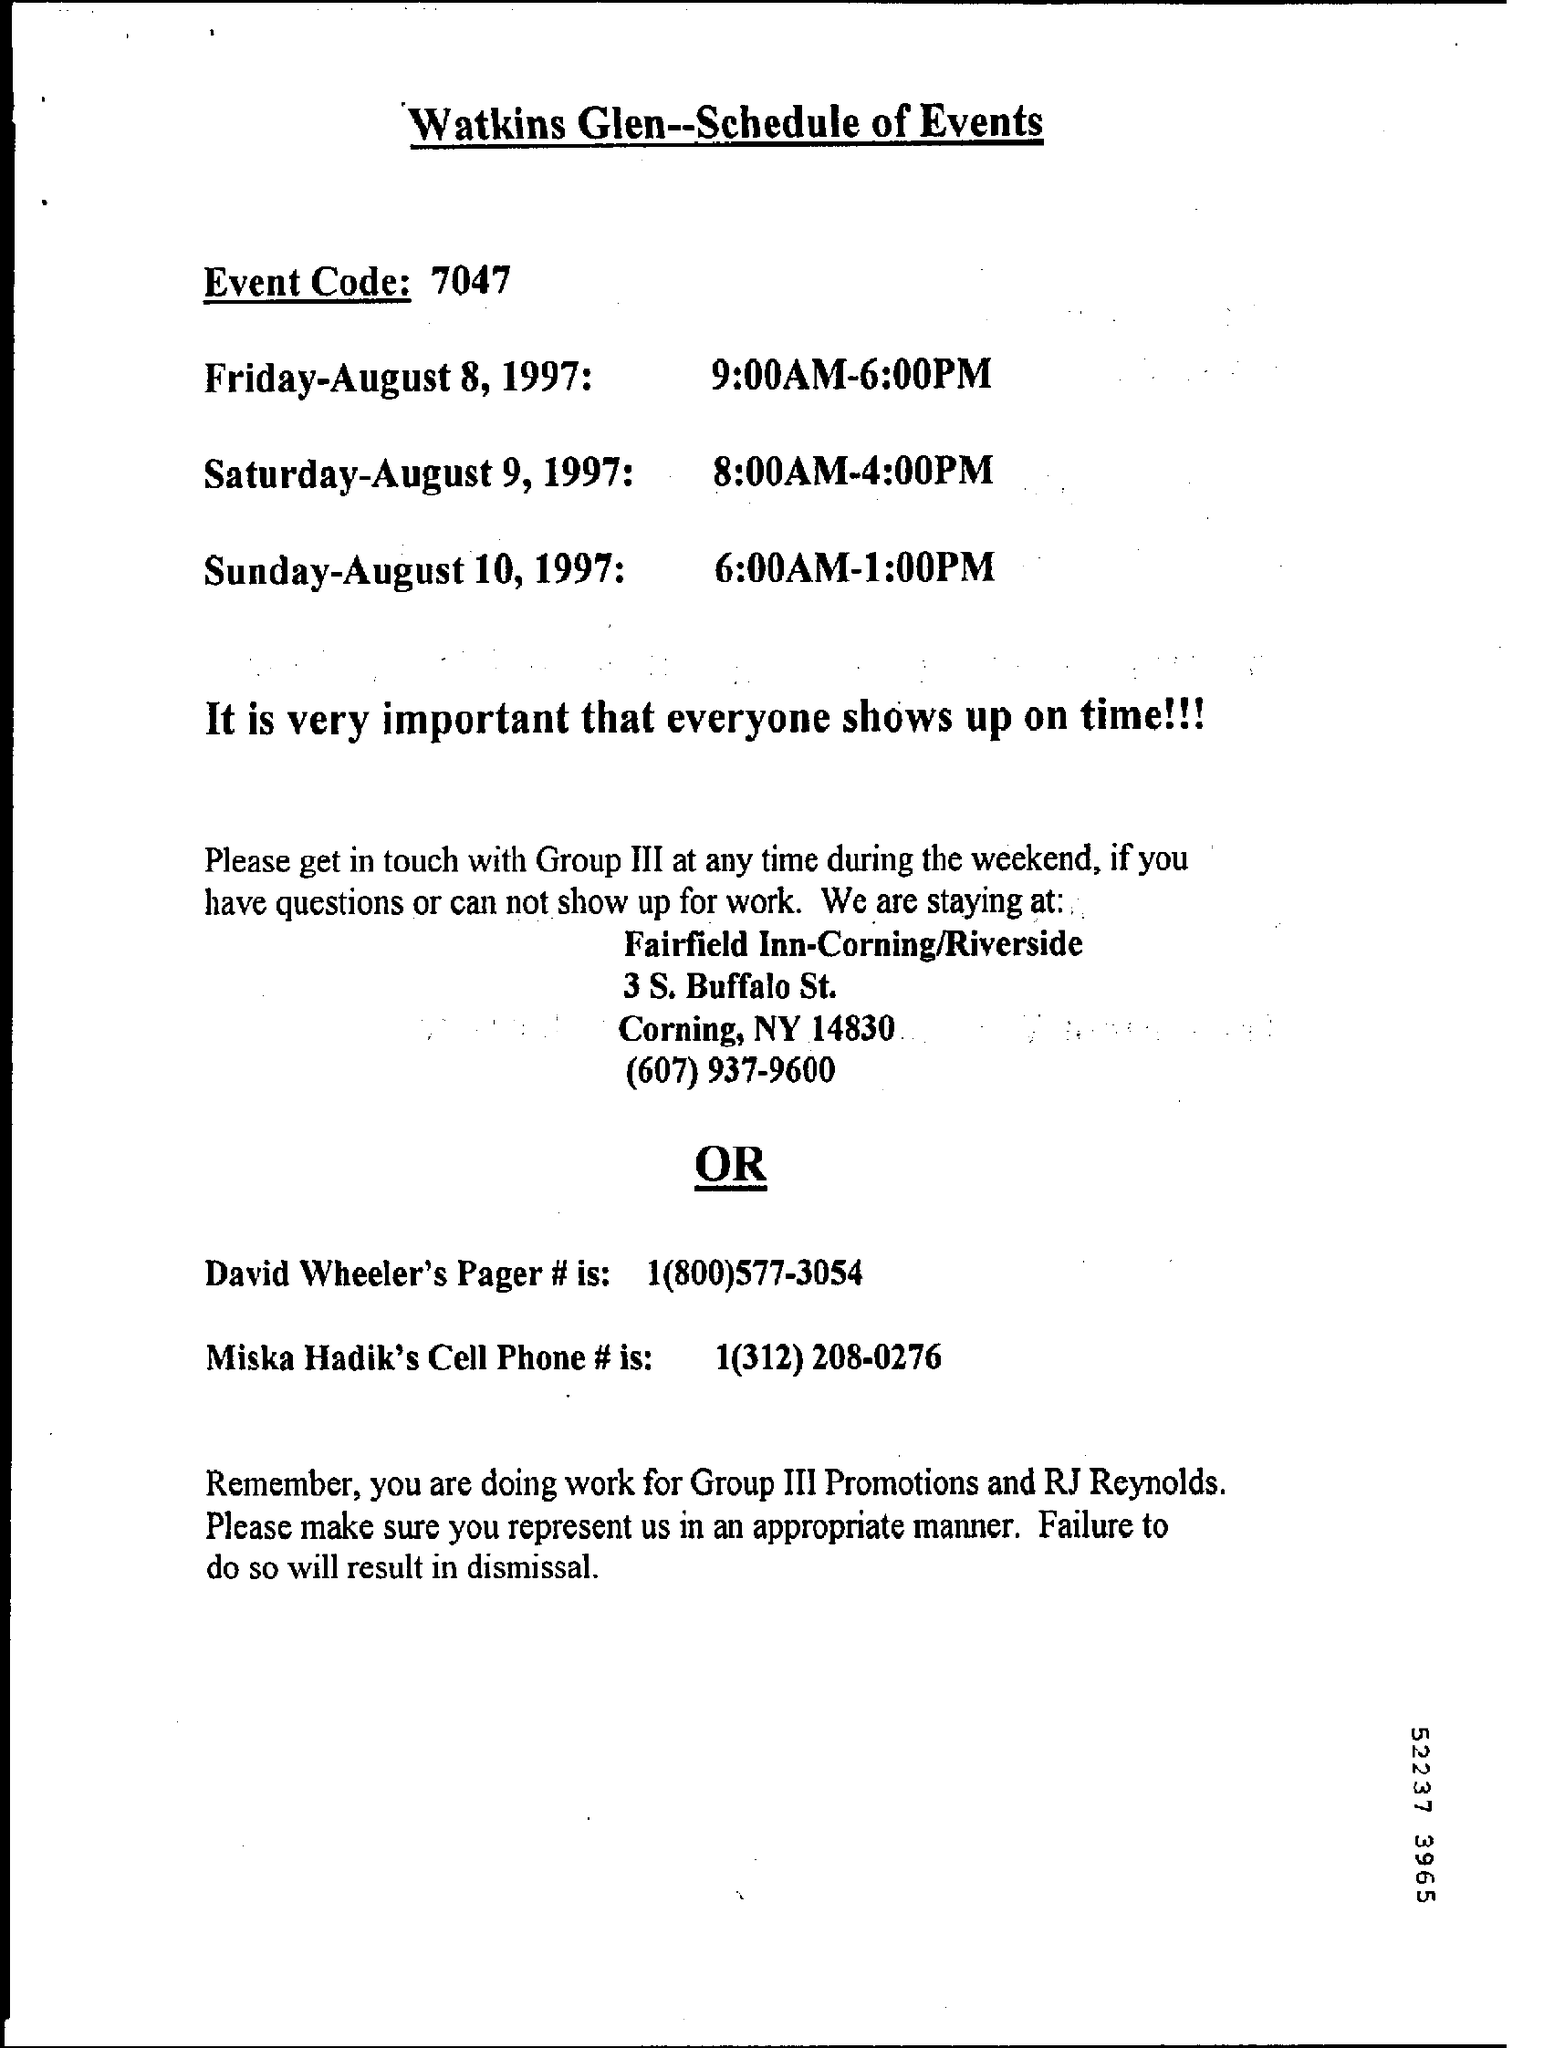Point out several critical features in this image. Please provide the event code, which is 7047... 